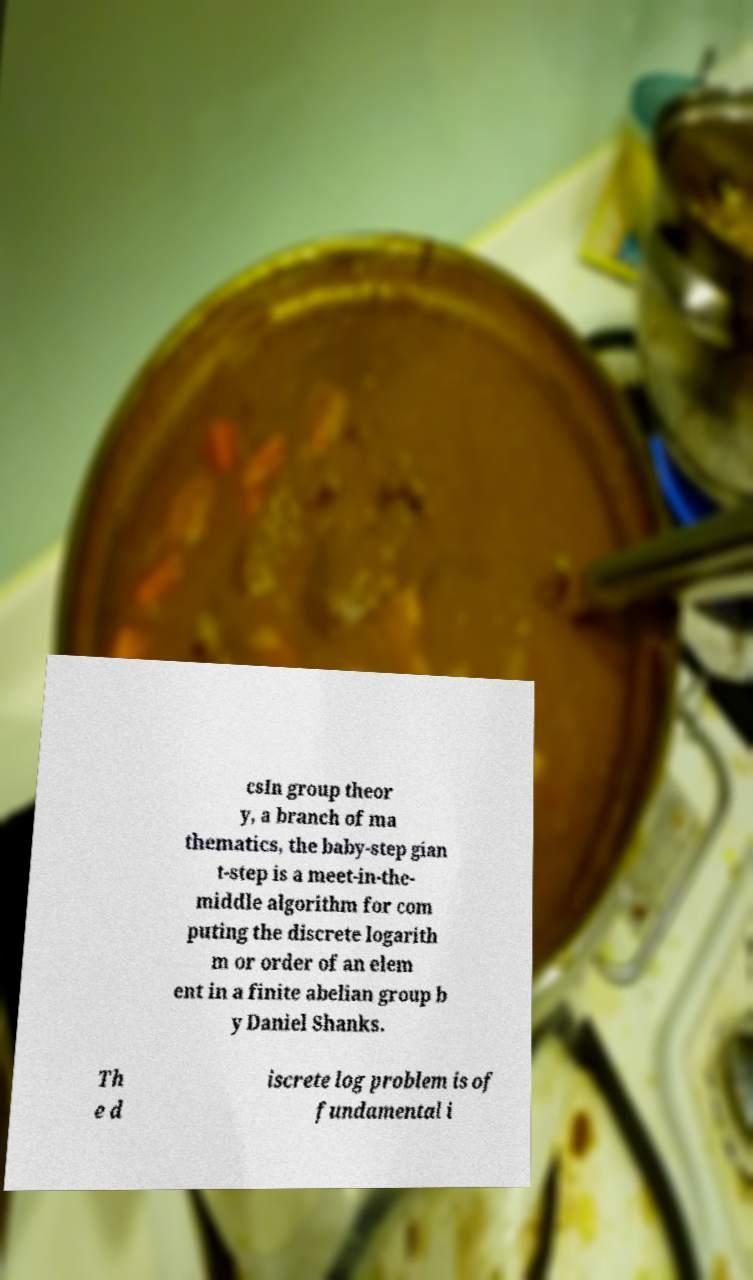There's text embedded in this image that I need extracted. Can you transcribe it verbatim? csIn group theor y, a branch of ma thematics, the baby-step gian t-step is a meet-in-the- middle algorithm for com puting the discrete logarith m or order of an elem ent in a finite abelian group b y Daniel Shanks. Th e d iscrete log problem is of fundamental i 